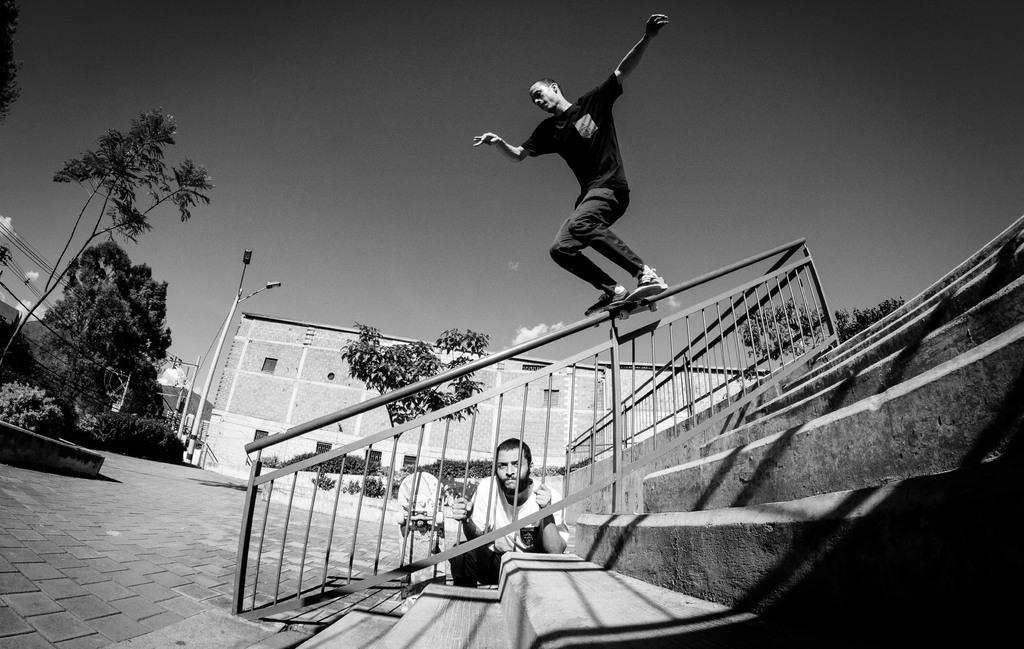How would you summarize this image in a sentence or two? In this image we can see a black and white picture of two persons. one person wearing black dress is skating on a metal railing. One person is holding metal rods in his hand. In the background, we can see staircase, a group of trees, poles, building and sky. 